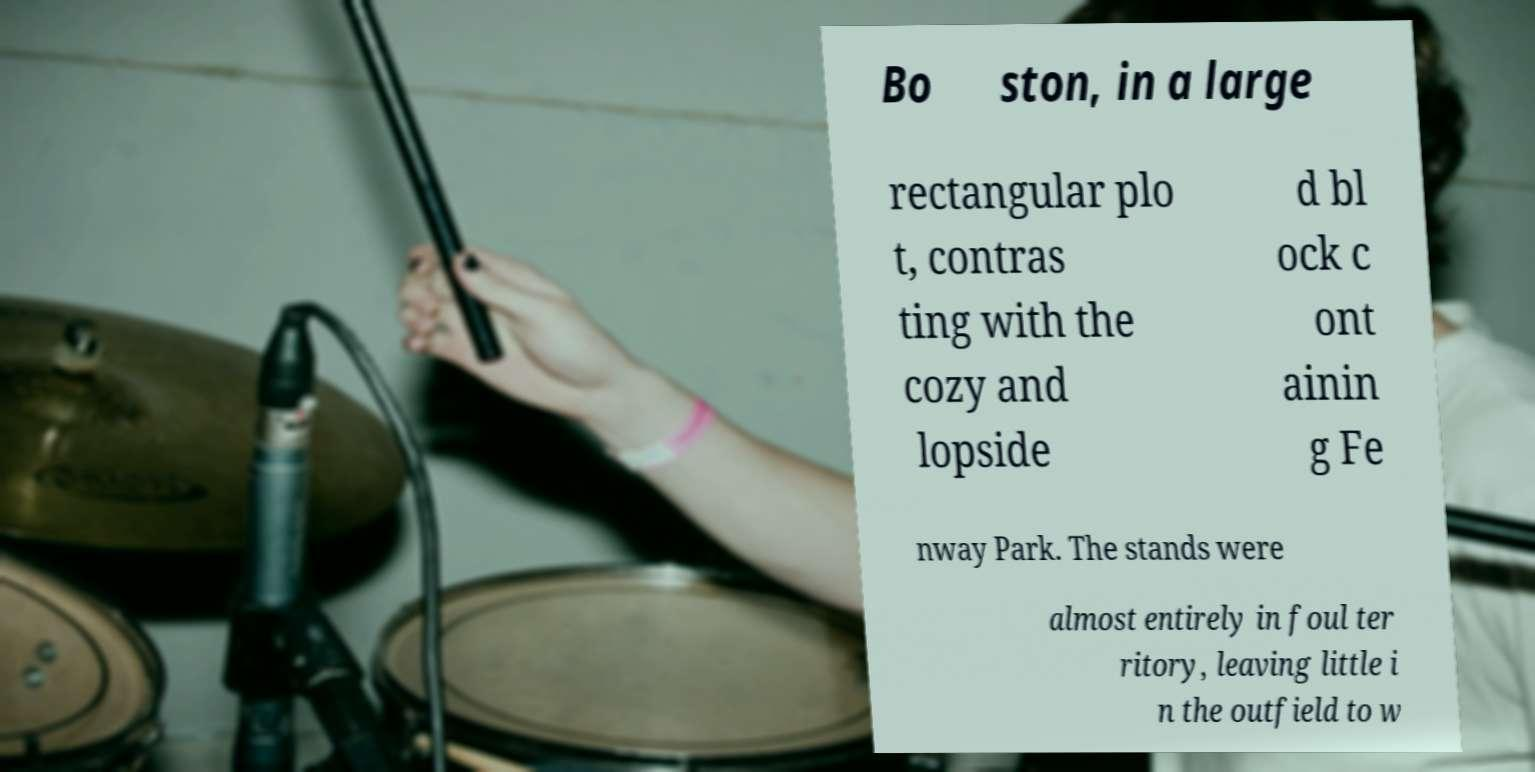Can you accurately transcribe the text from the provided image for me? Bo ston, in a large rectangular plo t, contras ting with the cozy and lopside d bl ock c ont ainin g Fe nway Park. The stands were almost entirely in foul ter ritory, leaving little i n the outfield to w 